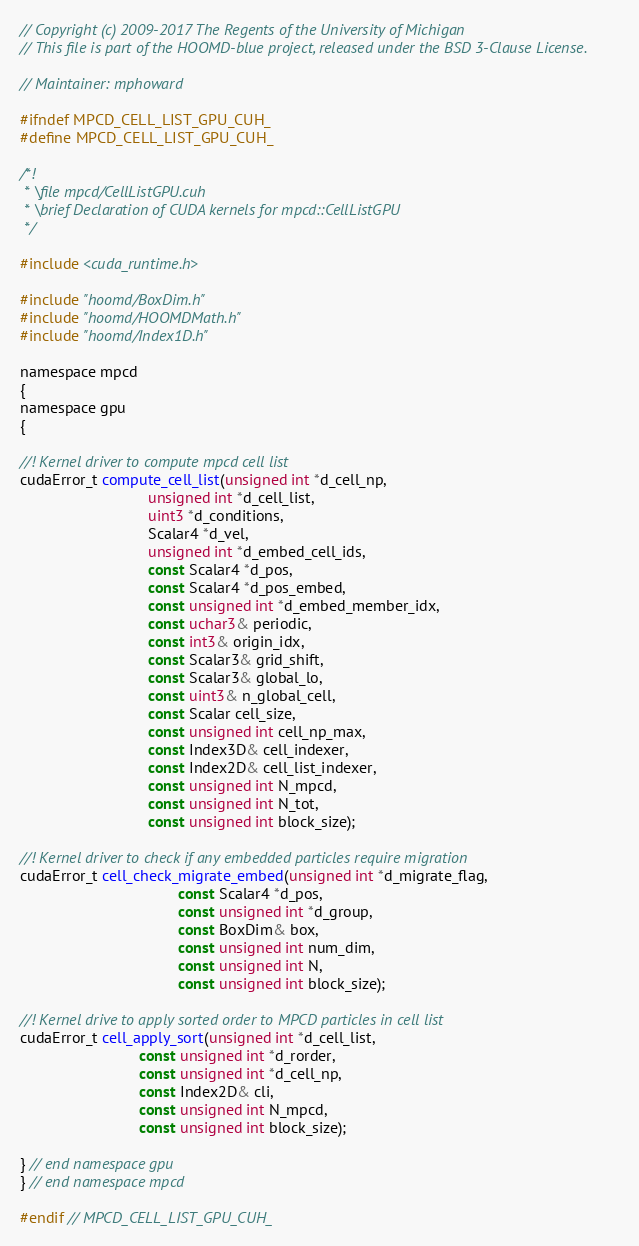Convert code to text. <code><loc_0><loc_0><loc_500><loc_500><_Cuda_>// Copyright (c) 2009-2017 The Regents of the University of Michigan
// This file is part of the HOOMD-blue project, released under the BSD 3-Clause License.

// Maintainer: mphoward

#ifndef MPCD_CELL_LIST_GPU_CUH_
#define MPCD_CELL_LIST_GPU_CUH_

/*!
 * \file mpcd/CellListGPU.cuh
 * \brief Declaration of CUDA kernels for mpcd::CellListGPU
 */

#include <cuda_runtime.h>

#include "hoomd/BoxDim.h"
#include "hoomd/HOOMDMath.h"
#include "hoomd/Index1D.h"

namespace mpcd
{
namespace gpu
{

//! Kernel driver to compute mpcd cell list
cudaError_t compute_cell_list(unsigned int *d_cell_np,
                              unsigned int *d_cell_list,
                              uint3 *d_conditions,
                              Scalar4 *d_vel,
                              unsigned int *d_embed_cell_ids,
                              const Scalar4 *d_pos,
                              const Scalar4 *d_pos_embed,
                              const unsigned int *d_embed_member_idx,
                              const uchar3& periodic,
                              const int3& origin_idx,
                              const Scalar3& grid_shift,
                              const Scalar3& global_lo,
                              const uint3& n_global_cell,
                              const Scalar cell_size,
                              const unsigned int cell_np_max,
                              const Index3D& cell_indexer,
                              const Index2D& cell_list_indexer,
                              const unsigned int N_mpcd,
                              const unsigned int N_tot,
                              const unsigned int block_size);

//! Kernel driver to check if any embedded particles require migration
cudaError_t cell_check_migrate_embed(unsigned int *d_migrate_flag,
                                     const Scalar4 *d_pos,
                                     const unsigned int *d_group,
                                     const BoxDim& box,
                                     const unsigned int num_dim,
                                     const unsigned int N,
                                     const unsigned int block_size);

//! Kernel drive to apply sorted order to MPCD particles in cell list
cudaError_t cell_apply_sort(unsigned int *d_cell_list,
                            const unsigned int *d_rorder,
                            const unsigned int *d_cell_np,
                            const Index2D& cli,
                            const unsigned int N_mpcd,
                            const unsigned int block_size);

} // end namespace gpu
} // end namespace mpcd

#endif // MPCD_CELL_LIST_GPU_CUH_
</code> 